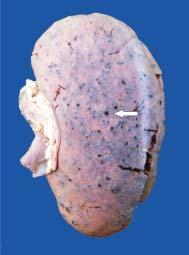does bilayer lipid membrane show tiny petechial haemorrhages visible through the capsule?
Answer the question using a single word or phrase. No 